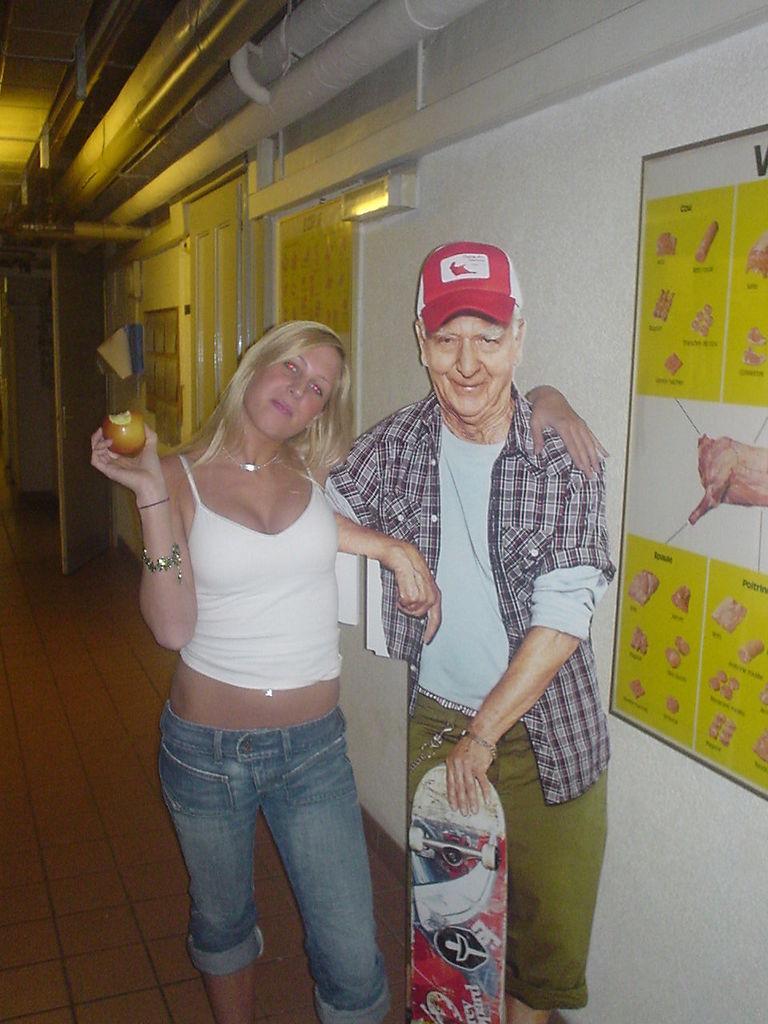Can you describe this image briefly? In this picture I can see a woman in front who is holding a fruit in her hand and I see a cardboard side to her which is of a man, who is holding a skateboard in his hand and I see the path. On the right side of this image I see the wall on which there is a paper, on which there are few pictures and I see something is written and on the top of this image I see the pipes. 